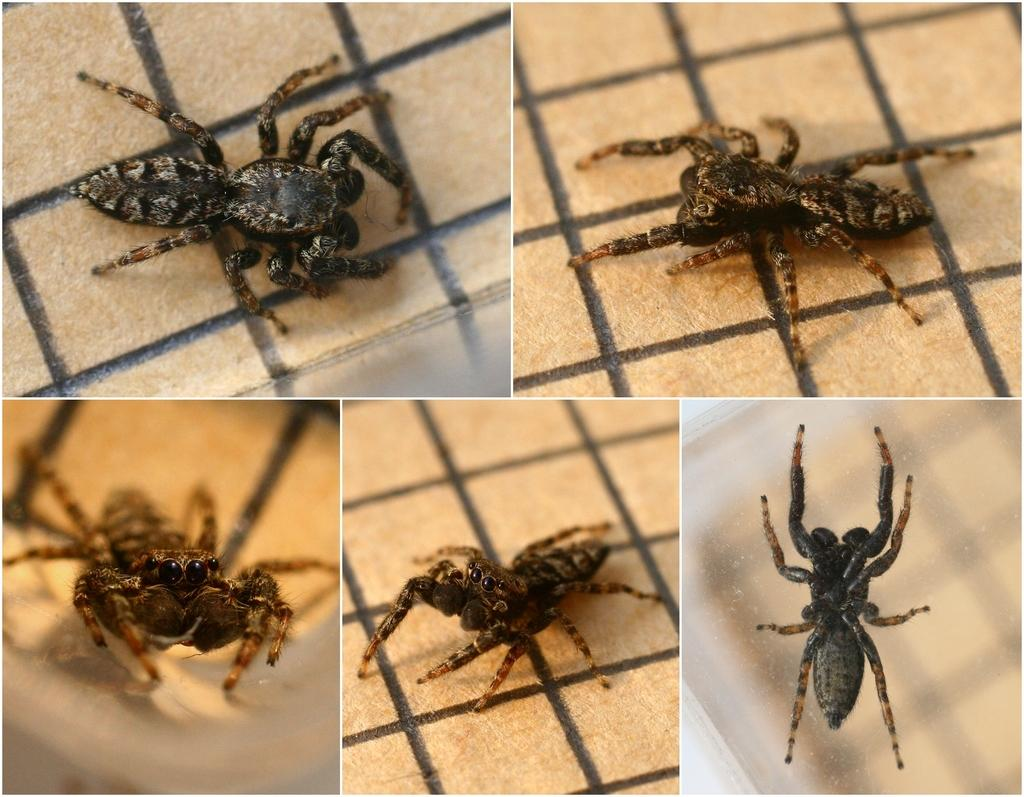What type of artwork is depicted in the image? The image is a collage. What creatures can be seen in the collage? There are spiders in the image. Where are the spiders located in the collage? The spiders are on the ground. What grade is the student receiving on their birthday in the image? There is no student, birthday, or grade present in the image; it is a collage featuring spiders on the ground. 